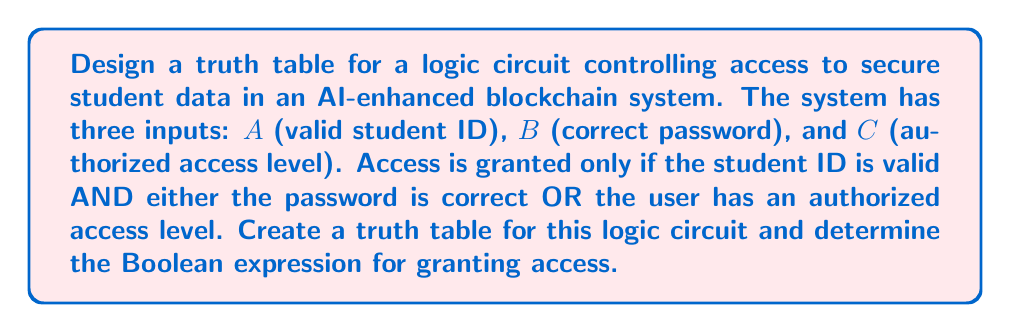Teach me how to tackle this problem. Let's approach this step-by-step:

1) First, we need to identify our inputs and output:
   Inputs: A (valid student ID), B (correct password), C (authorized access level)
   Output: X (access granted)

2) The logical condition for granting access can be expressed as:
   X = A AND (B OR C)

3) Now, let's create the truth table. With 3 inputs, we'll have $2^3 = 8$ rows:

   | A | B | C | B OR C | A AND (B OR C) |
   |---|---|---|--------|----------------|
   | 0 | 0 | 0 |   0    |       0        |
   | 0 | 0 | 1 |   1    |       0        |
   | 0 | 1 | 0 |   1    |       0        |
   | 0 | 1 | 1 |   1    |       0        |
   | 1 | 0 | 0 |   0    |       0        |
   | 1 | 0 | 1 |   1    |       1        |
   | 1 | 1 | 0 |   1    |       1        |
   | 1 | 1 | 1 |   1    |       1        |

4) From this truth table, we can confirm that the Boolean expression for granting access is:

   $$X = A \cdot (B + C)$$

   Where $\cdot$ represents AND and $+$ represents OR.

5) This expression can also be written in min-terms form:

   $$X = A \cdot B \cdot \overline{C} + A \cdot B \cdot C + A \cdot \overline{B} \cdot C$$

   Or more simply:

   $$X = A \cdot B + A \cdot C$$

This logic ensures that access is only granted when there's a valid student ID (A) AND either a correct password (B) or an authorized access level (C), aligning with the secure data access requirements of an AI-enhanced blockchain system for educational institutions.
Answer: The Boolean expression for granting access is: $$X = A \cdot (B + C)$$ or $$X = A \cdot B + A \cdot C$$ 